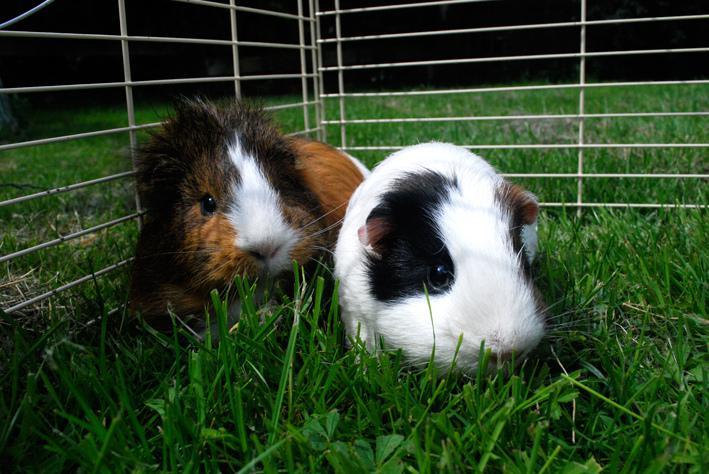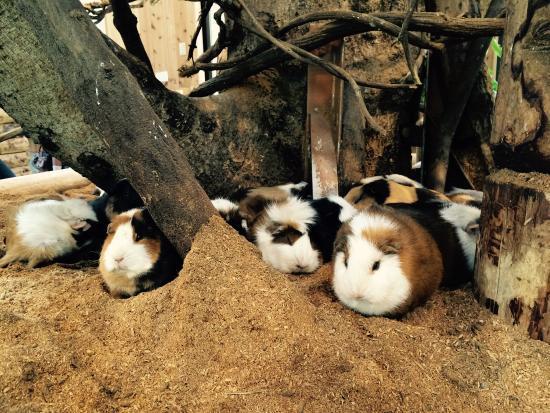The first image is the image on the left, the second image is the image on the right. Analyze the images presented: Is the assertion "Two gerbils are in a wire pen." valid? Answer yes or no. Yes. The first image is the image on the left, the second image is the image on the right. Analyze the images presented: Is the assertion "There are 5 hamsters in the grass." valid? Answer yes or no. No. 